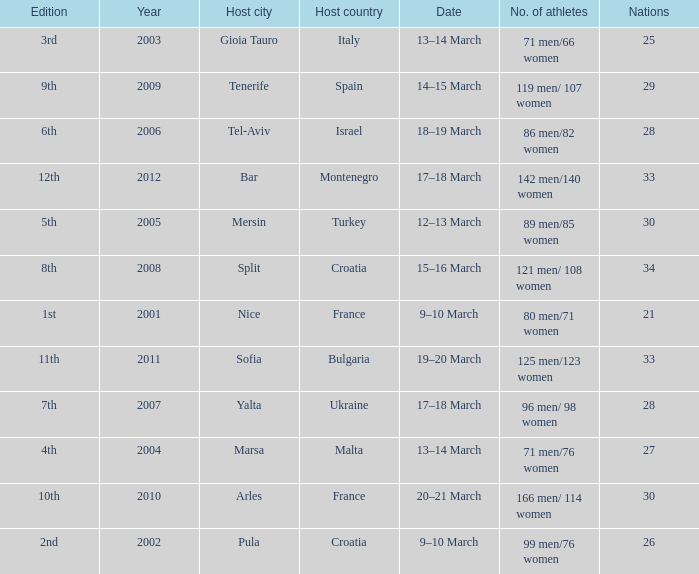What was the host city of the 8th edition in the the host country of Croatia? Split. 